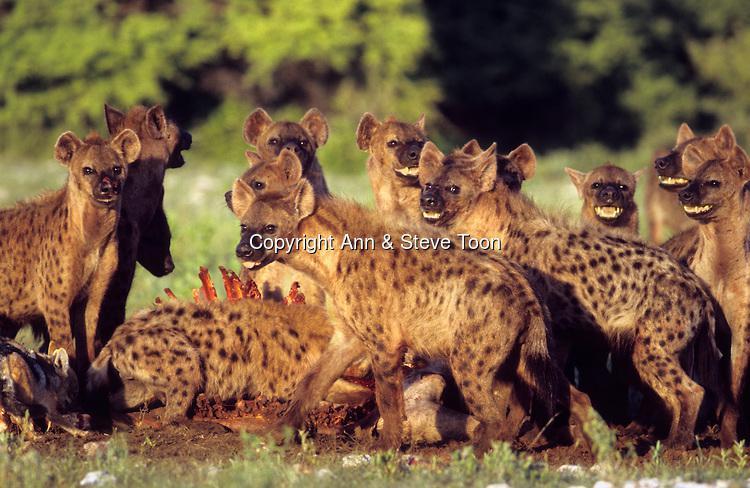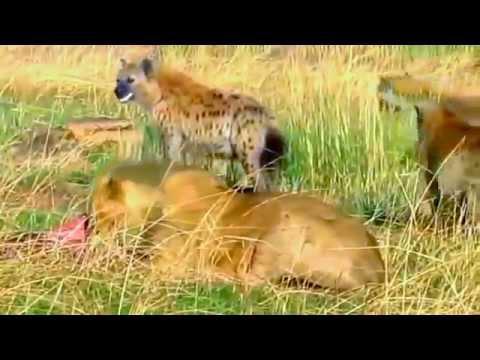The first image is the image on the left, the second image is the image on the right. Assess this claim about the two images: "A lion is bleeding in one of the images.". Correct or not? Answer yes or no. No. The first image is the image on the left, the second image is the image on the right. For the images displayed, is the sentence "An image shows many 'smiling' hyenas with upraised heads around a carcass with ribs showing." factually correct? Answer yes or no. Yes. 